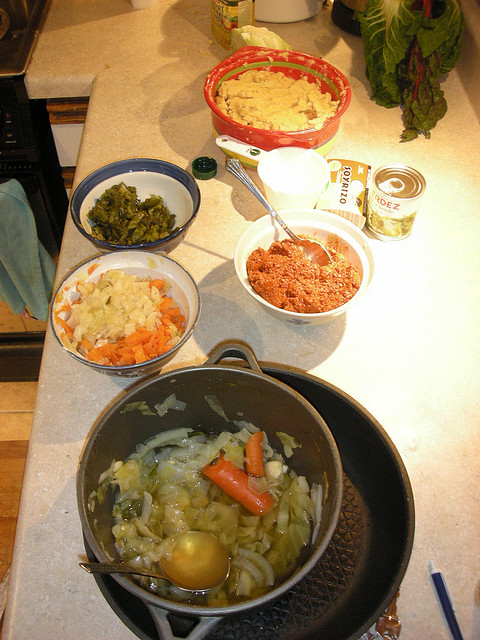How many people are posing for a photo? There are no people in the image to pose for a photo. The image shows a kitchen counter with various bowls and pots containing different food ingredients and items like vegetables and what seems to be ground meat. 